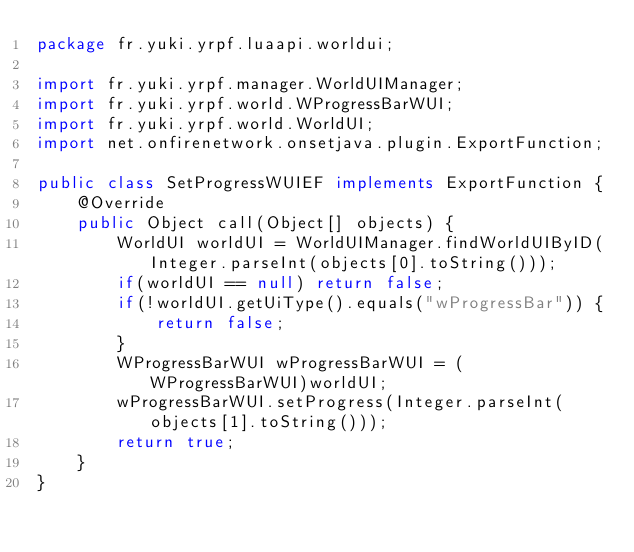Convert code to text. <code><loc_0><loc_0><loc_500><loc_500><_Java_>package fr.yuki.yrpf.luaapi.worldui;

import fr.yuki.yrpf.manager.WorldUIManager;
import fr.yuki.yrpf.world.WProgressBarWUI;
import fr.yuki.yrpf.world.WorldUI;
import net.onfirenetwork.onsetjava.plugin.ExportFunction;

public class SetProgressWUIEF implements ExportFunction {
    @Override
    public Object call(Object[] objects) {
        WorldUI worldUI = WorldUIManager.findWorldUIByID(Integer.parseInt(objects[0].toString()));
        if(worldUI == null) return false;
        if(!worldUI.getUiType().equals("wProgressBar")) {
            return false;
        }
        WProgressBarWUI wProgressBarWUI = (WProgressBarWUI)worldUI;
        wProgressBarWUI.setProgress(Integer.parseInt(objects[1].toString()));
        return true;
    }
}
</code> 